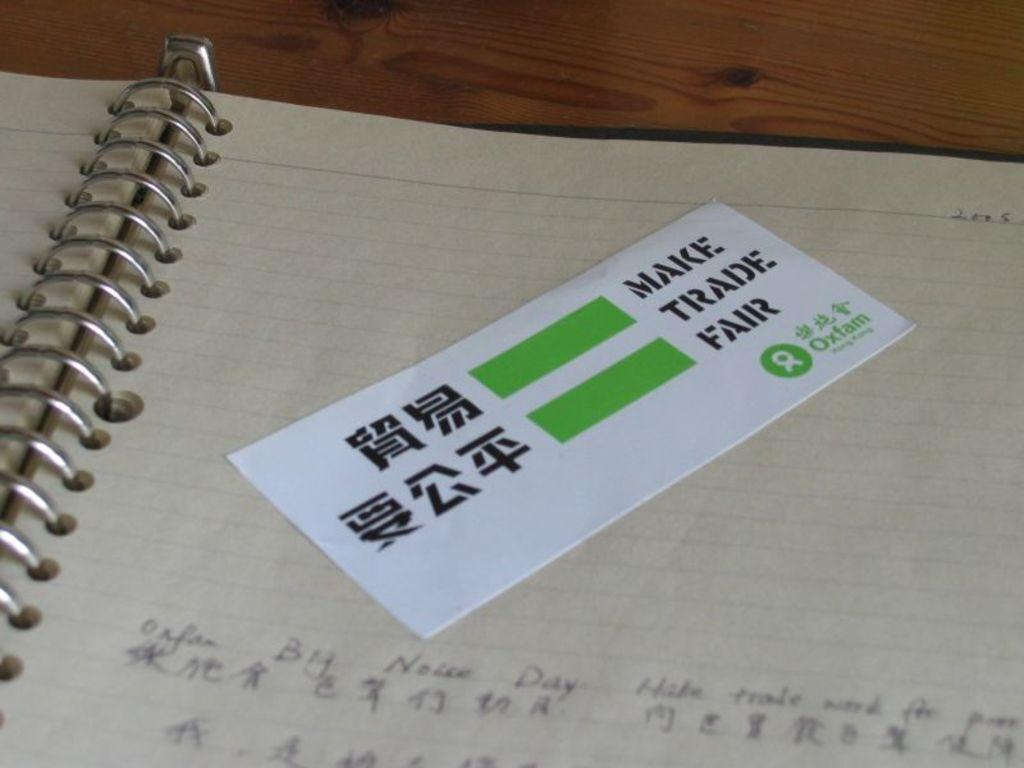Provide a one-sentence caption for the provided image. Make trade Fair ticket sits on top of the page of a notebook. 